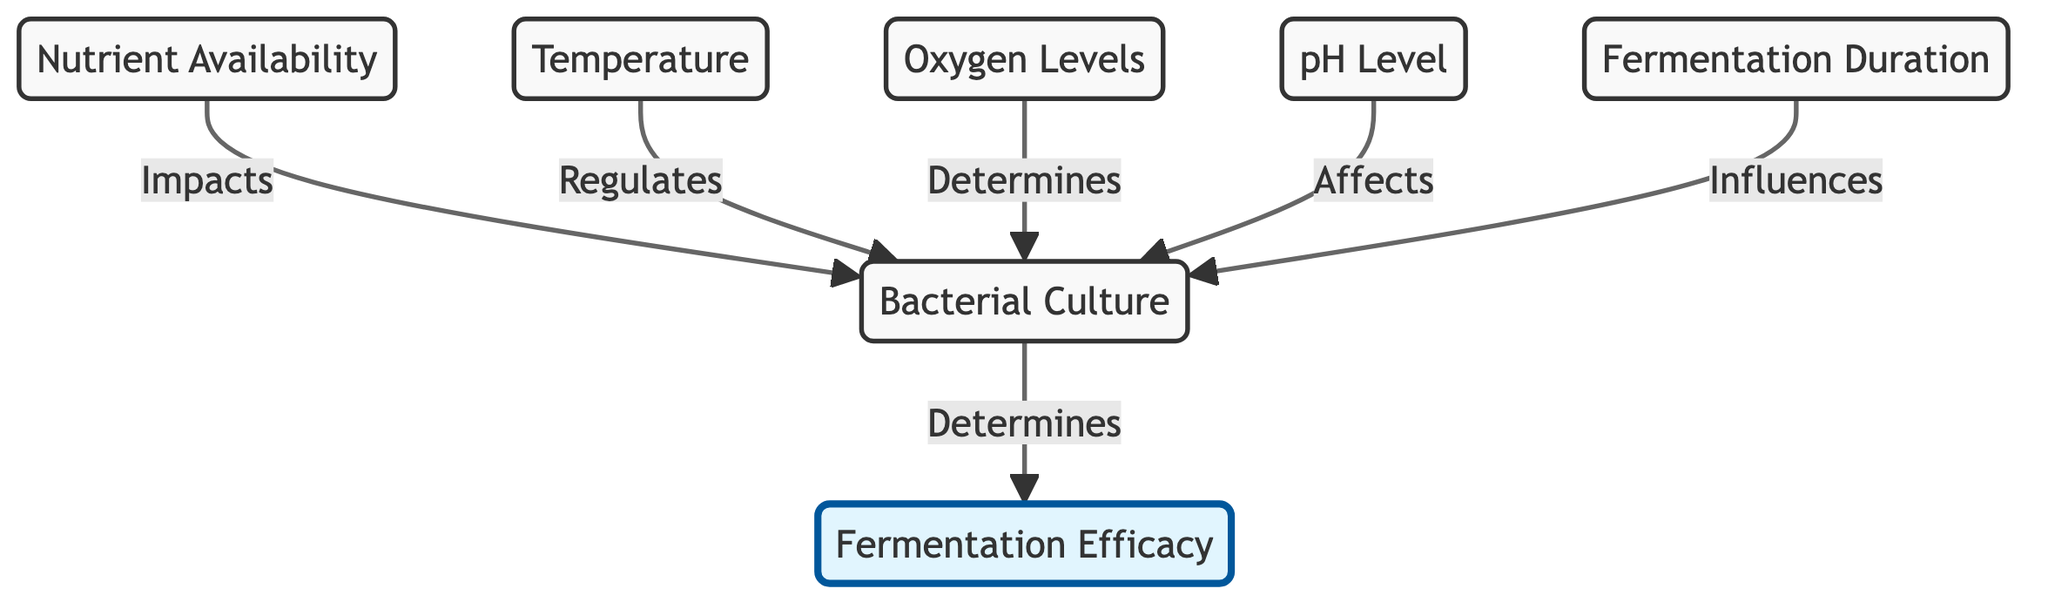What does "Fermentation Efficacy" depend on? The diagram illustrates that "Fermentation Efficacy" is determined by the "Bacterial Culture." The arrow indicates a direct relationship where the effectiveness of fermentation is linked to the specific strains used.
Answer: Bacterial Culture How many factors influence "Bacterial Culture"? The diagram shows five arrows leading to "Bacterial Culture," indicating that five different factors influence it. This includes "Nutrient Availability," "Temperature," "Oxygen Levels," "pH Level," and "Fermentation Duration."
Answer: 5 What is the role of "Temperature" in the diagram? "Temperature" regulates "Bacterial Culture," according to the directed edge that portrays the influencing relationship from temperature to bacterial strains. This means that temperature settings affect which bacterial cultures can thrive during fermentation.
Answer: Regulates Which element affects the fermentation process besides "Bacterial Culture"? The diagram lists "Nutrient Availability," "Temperature," "Oxygen Levels," "pH Level," and "Fermentation Duration" as elements that affect "Bacterial Culture," which in turn affects "Fermentation Efficacy." Since it asks specifically for elements other than "Bacterial Culture," the answer is one of the influencing factors.
Answer: Nutrient Availability, Temperature, Oxygen Levels, pH Level, Fermentation Duration How many environmental factors are represented in the chart? The environmental factors represented in the chart are "Nutrient Availability," "Temperature," "Oxygen Levels," and "pH Level." Counting these nodes provides the total number of specific environmental factors that relate to bacterial growth conditions during fermentation.
Answer: 4 What is the final outcome of the interactions in the diagram? The final outcome of the interactions depicted in the diagram is "Fermentation Efficacy." This result derives from the influences and relationships established between the various input factors and the bacterial culture.
Answer: Fermentation Efficacy Which node has the most connections in this diagram? Analyzing the directed edges leading from multiple nodes, "Bacterial Culture" has five incoming connections from "Nutrient Availability," "Temperature," "Oxygen Levels," "pH Level," and "Fermentation Duration." This makes it the most connected node in the flow chart.
Answer: Bacterial Culture What does "pH Level" affect? The diagram shows an arrow pointing from "pH Level" to "Bacterial Culture," indicating that pH level affects the bacterial strains during fermentation, influencing their growth and activity.
Answer: Bacterial Culture 